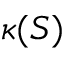<formula> <loc_0><loc_0><loc_500><loc_500>\kappa ( S )</formula> 